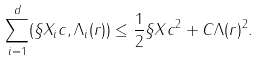Convert formula to latex. <formula><loc_0><loc_0><loc_500><loc_500>\sum _ { i = 1 } ^ { d } ( \S X _ { i } c , \Lambda _ { i } ( r ) ) \leq \frac { 1 } { 2 } \| \S X c \| ^ { 2 } + C \| \Lambda ( r ) \| ^ { 2 } .</formula> 